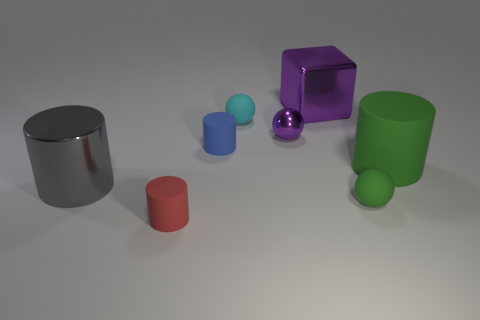What material is the small green object that is the same shape as the tiny cyan rubber thing?
Offer a terse response. Rubber. Is the number of blue matte things greater than the number of tiny yellow rubber cylinders?
Offer a terse response. Yes. Is the color of the tiny shiny object the same as the shiny object that is to the right of the purple metallic ball?
Ensure brevity in your answer.  Yes. There is a large object that is to the left of the green matte sphere and on the right side of the red rubber thing; what is its color?
Provide a succinct answer. Purple. How many other things are there of the same material as the green ball?
Your answer should be very brief. 4. Is the number of tiny brown metallic spheres less than the number of tiny purple balls?
Keep it short and to the point. Yes. Do the tiny green ball and the purple cube on the right side of the gray metal thing have the same material?
Your answer should be very brief. No. There is a object to the right of the tiny green matte sphere; what shape is it?
Your response must be concise. Cylinder. Is there any other thing that has the same color as the large metallic cylinder?
Your response must be concise. No. Are there fewer small cylinders that are right of the cyan sphere than cyan balls?
Give a very brief answer. Yes. 